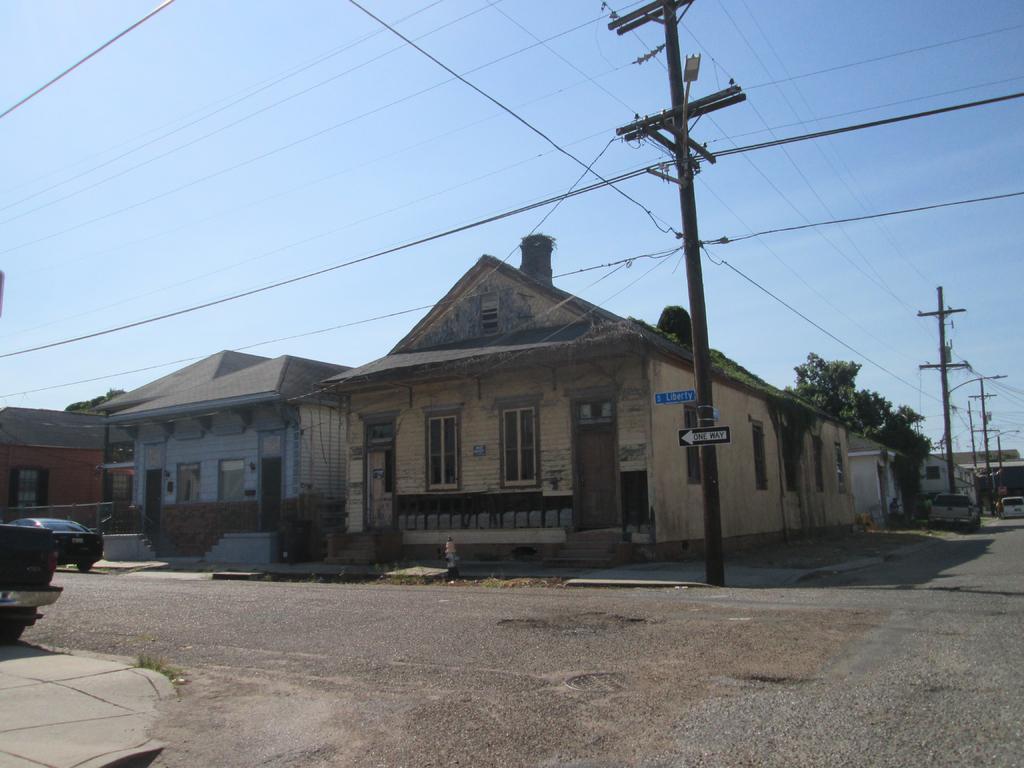In one or two sentences, can you explain what this image depicts? In this image we can see vehicles on the road on the left and right side and in the background there are houses, windows, doors, boards on a pole, wire, street lights, poles, trees, hydrant and sky. 